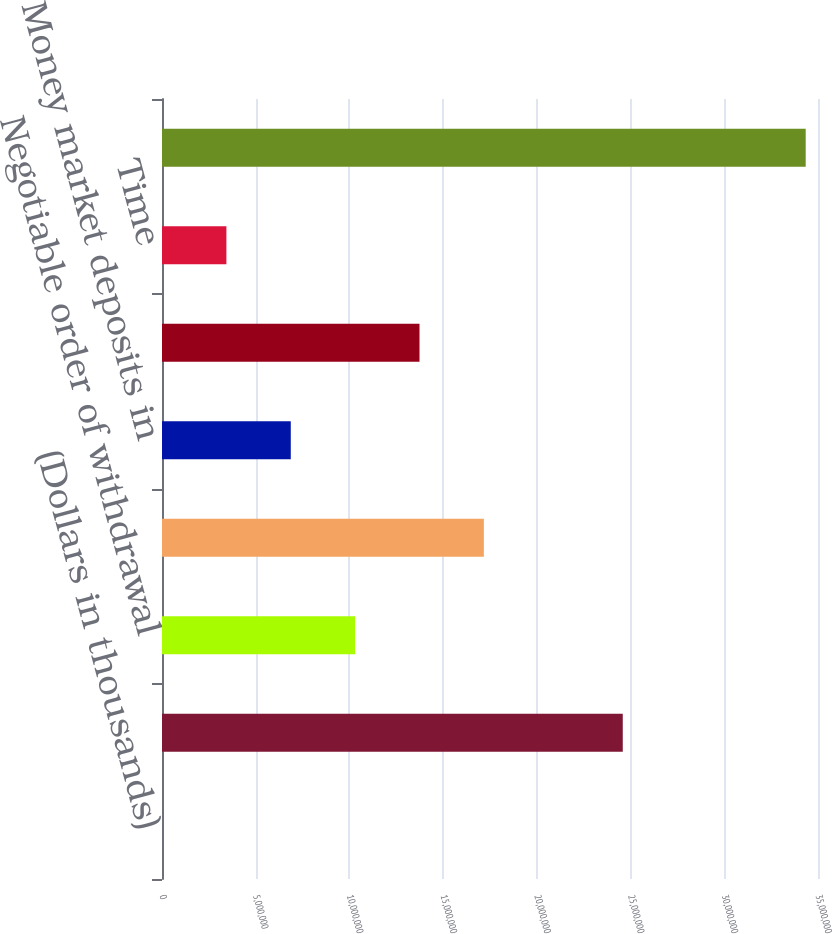<chart> <loc_0><loc_0><loc_500><loc_500><bar_chart><fcel>(Dollars in thousands)<fcel>Noninterest-bearing demand<fcel>Negotiable order of withdrawal<fcel>Money market<fcel>Money market deposits in<fcel>Sweep deposits in foreign<fcel>Time<fcel>Total deposits<nl><fcel>2014<fcel>2.45837e+07<fcel>1.03045e+07<fcel>1.71728e+07<fcel>6.87031e+06<fcel>1.37386e+07<fcel>3.43616e+06<fcel>3.43435e+07<nl></chart> 